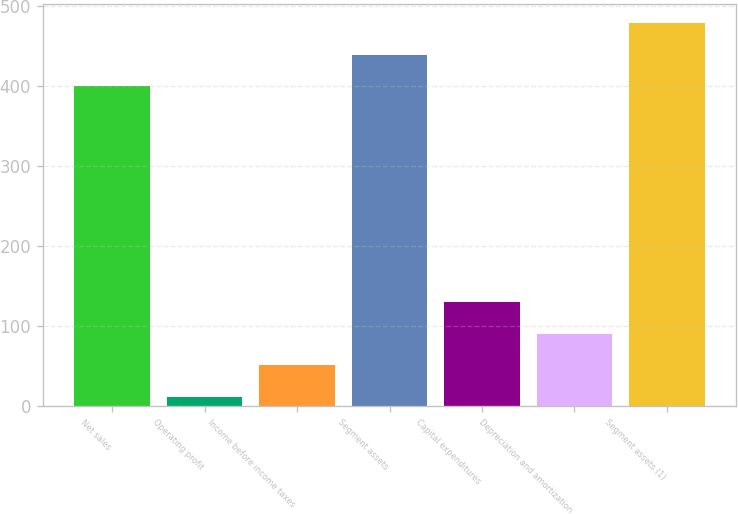Convert chart. <chart><loc_0><loc_0><loc_500><loc_500><bar_chart><fcel>Net sales<fcel>Operating profit<fcel>Income before income taxes<fcel>Segment assets<fcel>Capital expenditures<fcel>Depreciation and amortization<fcel>Segment assets (1)<nl><fcel>400.2<fcel>12<fcel>51.31<fcel>439.51<fcel>129.93<fcel>90.62<fcel>478.82<nl></chart> 